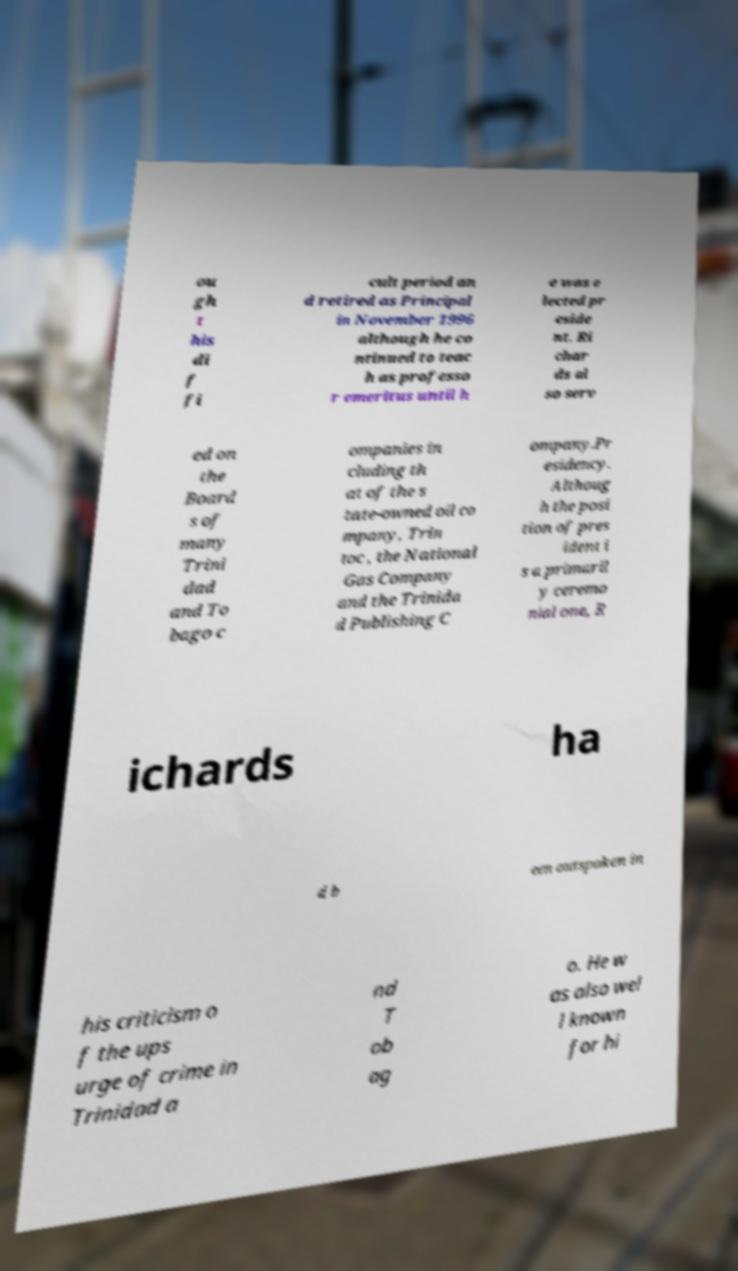Could you assist in decoding the text presented in this image and type it out clearly? ou gh t his di f fi cult period an d retired as Principal in November 1996 although he co ntinued to teac h as professo r emeritus until h e was e lected pr eside nt. Ri char ds al so serv ed on the Board s of many Trini dad and To bago c ompanies in cluding th at of the s tate-owned oil co mpany, Trin toc , the National Gas Company and the Trinida d Publishing C ompany.Pr esidency. Althoug h the posi tion of pres ident i s a primaril y ceremo nial one, R ichards ha d b een outspoken in his criticism o f the ups urge of crime in Trinidad a nd T ob ag o. He w as also wel l known for hi 